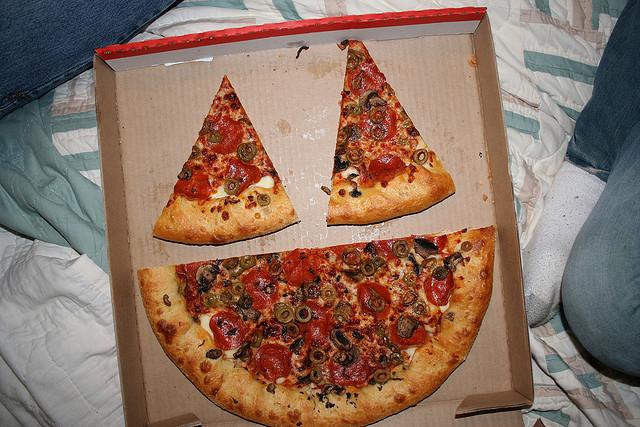How many slices of pizza are there?
Give a very brief answer. 2. What are the pizzas sitting in?
Quick response, please. Box. What is the pizza sitting on?
Answer briefly. Box. What has the pizza been formed to look like?
Keep it brief. Smiley face. How many single slices are there?
Concise answer only. 2. 